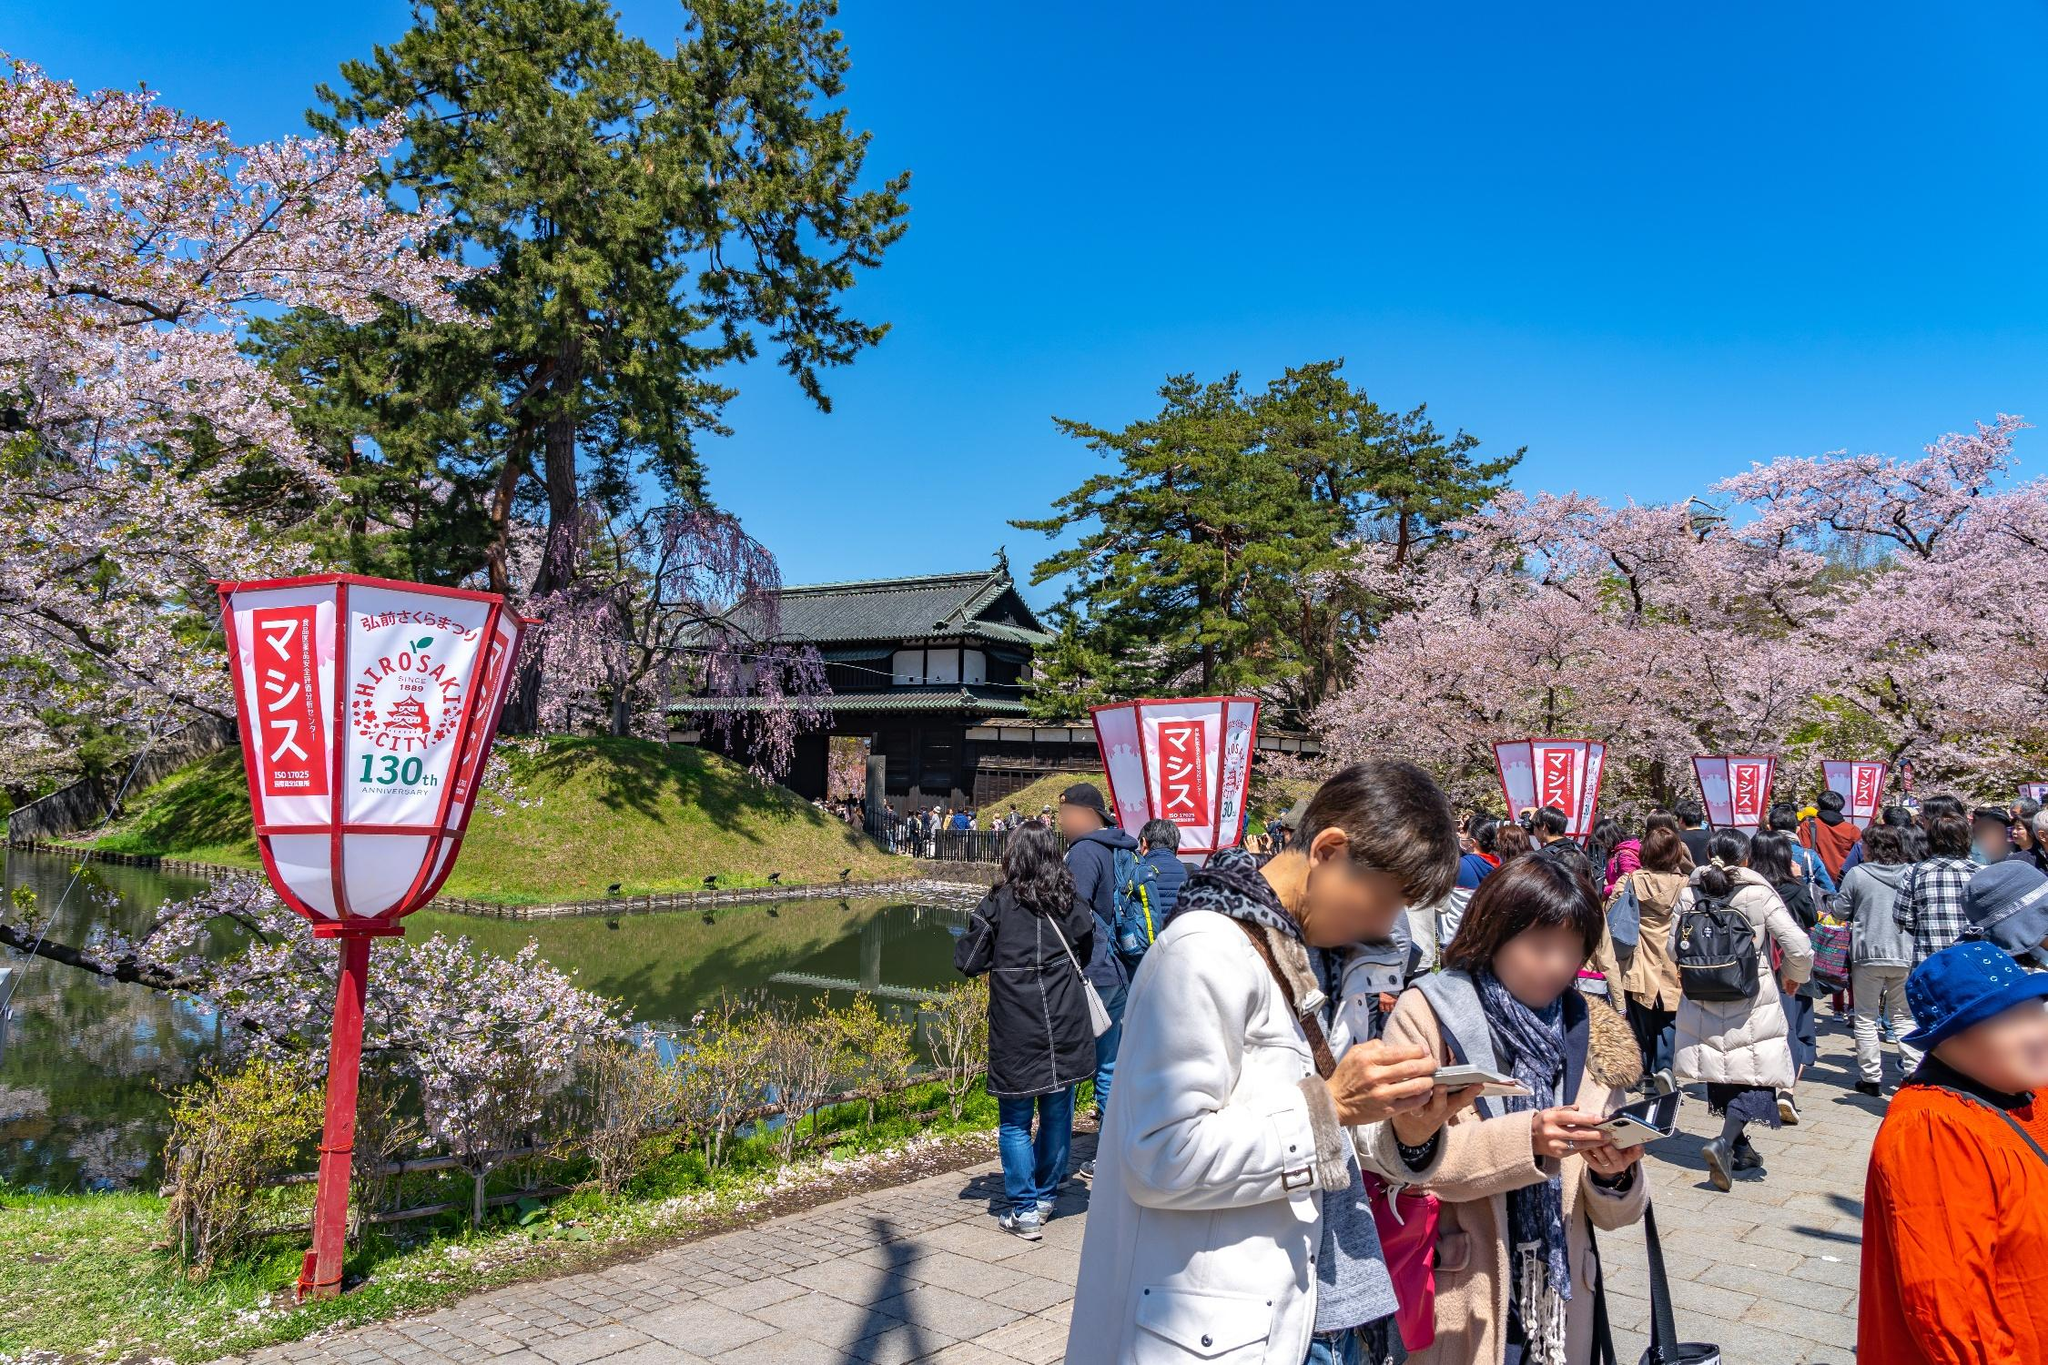What different activities can you see people engaging in? In the image, people are seen strolling along the path, enjoying the beauty of the cherry blossoms. Many are capturing the moment with their cameras or smartphones. Some appear to be chatting in small groups, while others are more engrossed in the scenery. It’s also likely that there are food stalls and vendors selling souvenirs as part of the festival atmosphere. What else might visitors do at this festival? Aside from strolling and taking pictures, visitors at the Hirosaki Castle cherry blossom festival might enjoy traditional Japanese performances, participate in tea ceremonies under the blossoms, and experience local culinary delights from various food stalls. They may also take boat rides in the moat, listen to musical performances, and participate in hanami parties where they can have picnics under the cherry trees. 